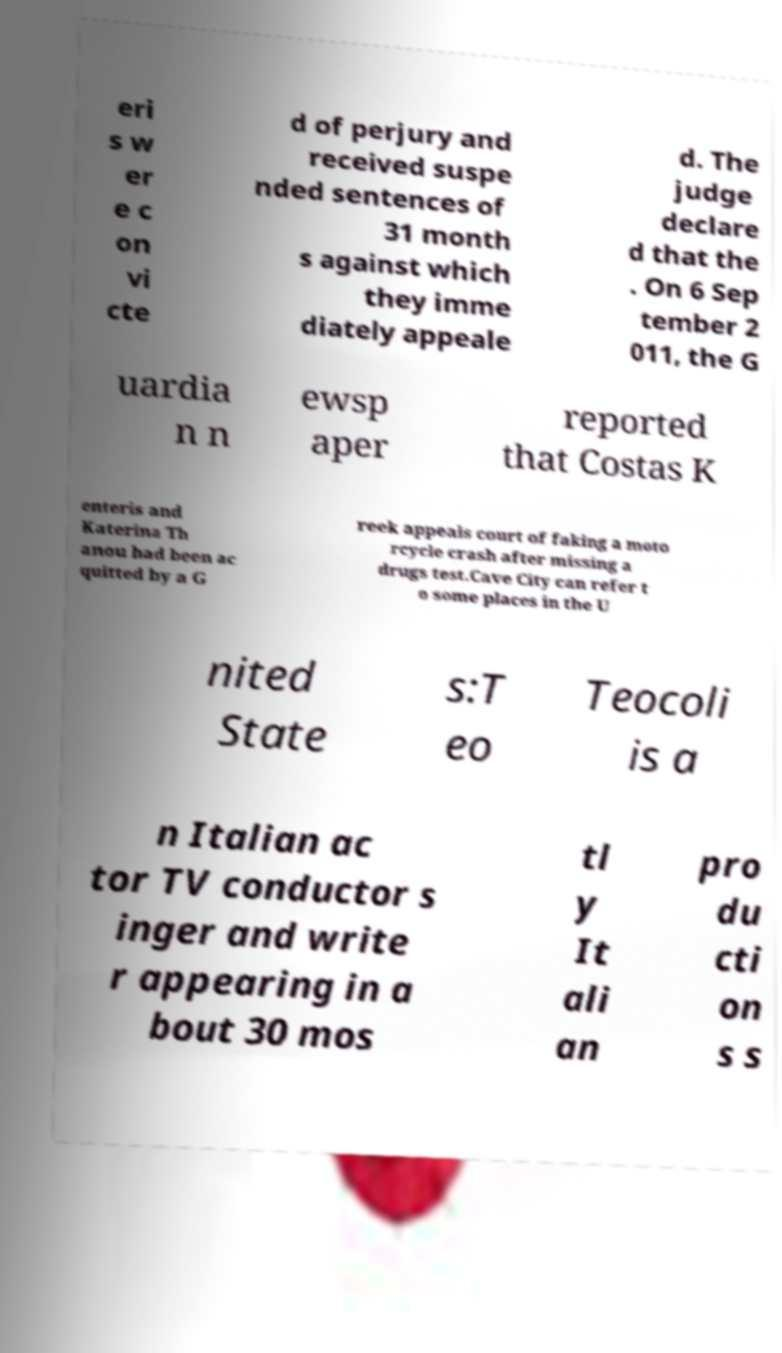Can you accurately transcribe the text from the provided image for me? eri s w er e c on vi cte d of perjury and received suspe nded sentences of 31 month s against which they imme diately appeale d. The judge declare d that the . On 6 Sep tember 2 011, the G uardia n n ewsp aper reported that Costas K enteris and Katerina Th anou had been ac quitted by a G reek appeals court of faking a moto rcycle crash after missing a drugs test.Cave City can refer t o some places in the U nited State s:T eo Teocoli is a n Italian ac tor TV conductor s inger and write r appearing in a bout 30 mos tl y It ali an pro du cti on s s 